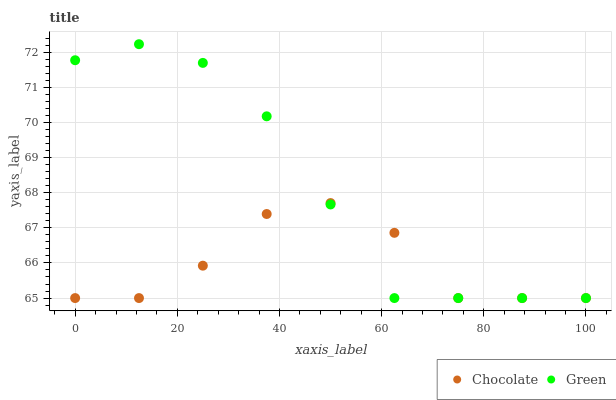Does Chocolate have the minimum area under the curve?
Answer yes or no. Yes. Does Green have the maximum area under the curve?
Answer yes or no. Yes. Does Chocolate have the maximum area under the curve?
Answer yes or no. No. Is Green the smoothest?
Answer yes or no. Yes. Is Chocolate the roughest?
Answer yes or no. Yes. Is Chocolate the smoothest?
Answer yes or no. No. Does Green have the lowest value?
Answer yes or no. Yes. Does Green have the highest value?
Answer yes or no. Yes. Does Chocolate have the highest value?
Answer yes or no. No. Does Chocolate intersect Green?
Answer yes or no. Yes. Is Chocolate less than Green?
Answer yes or no. No. Is Chocolate greater than Green?
Answer yes or no. No. 